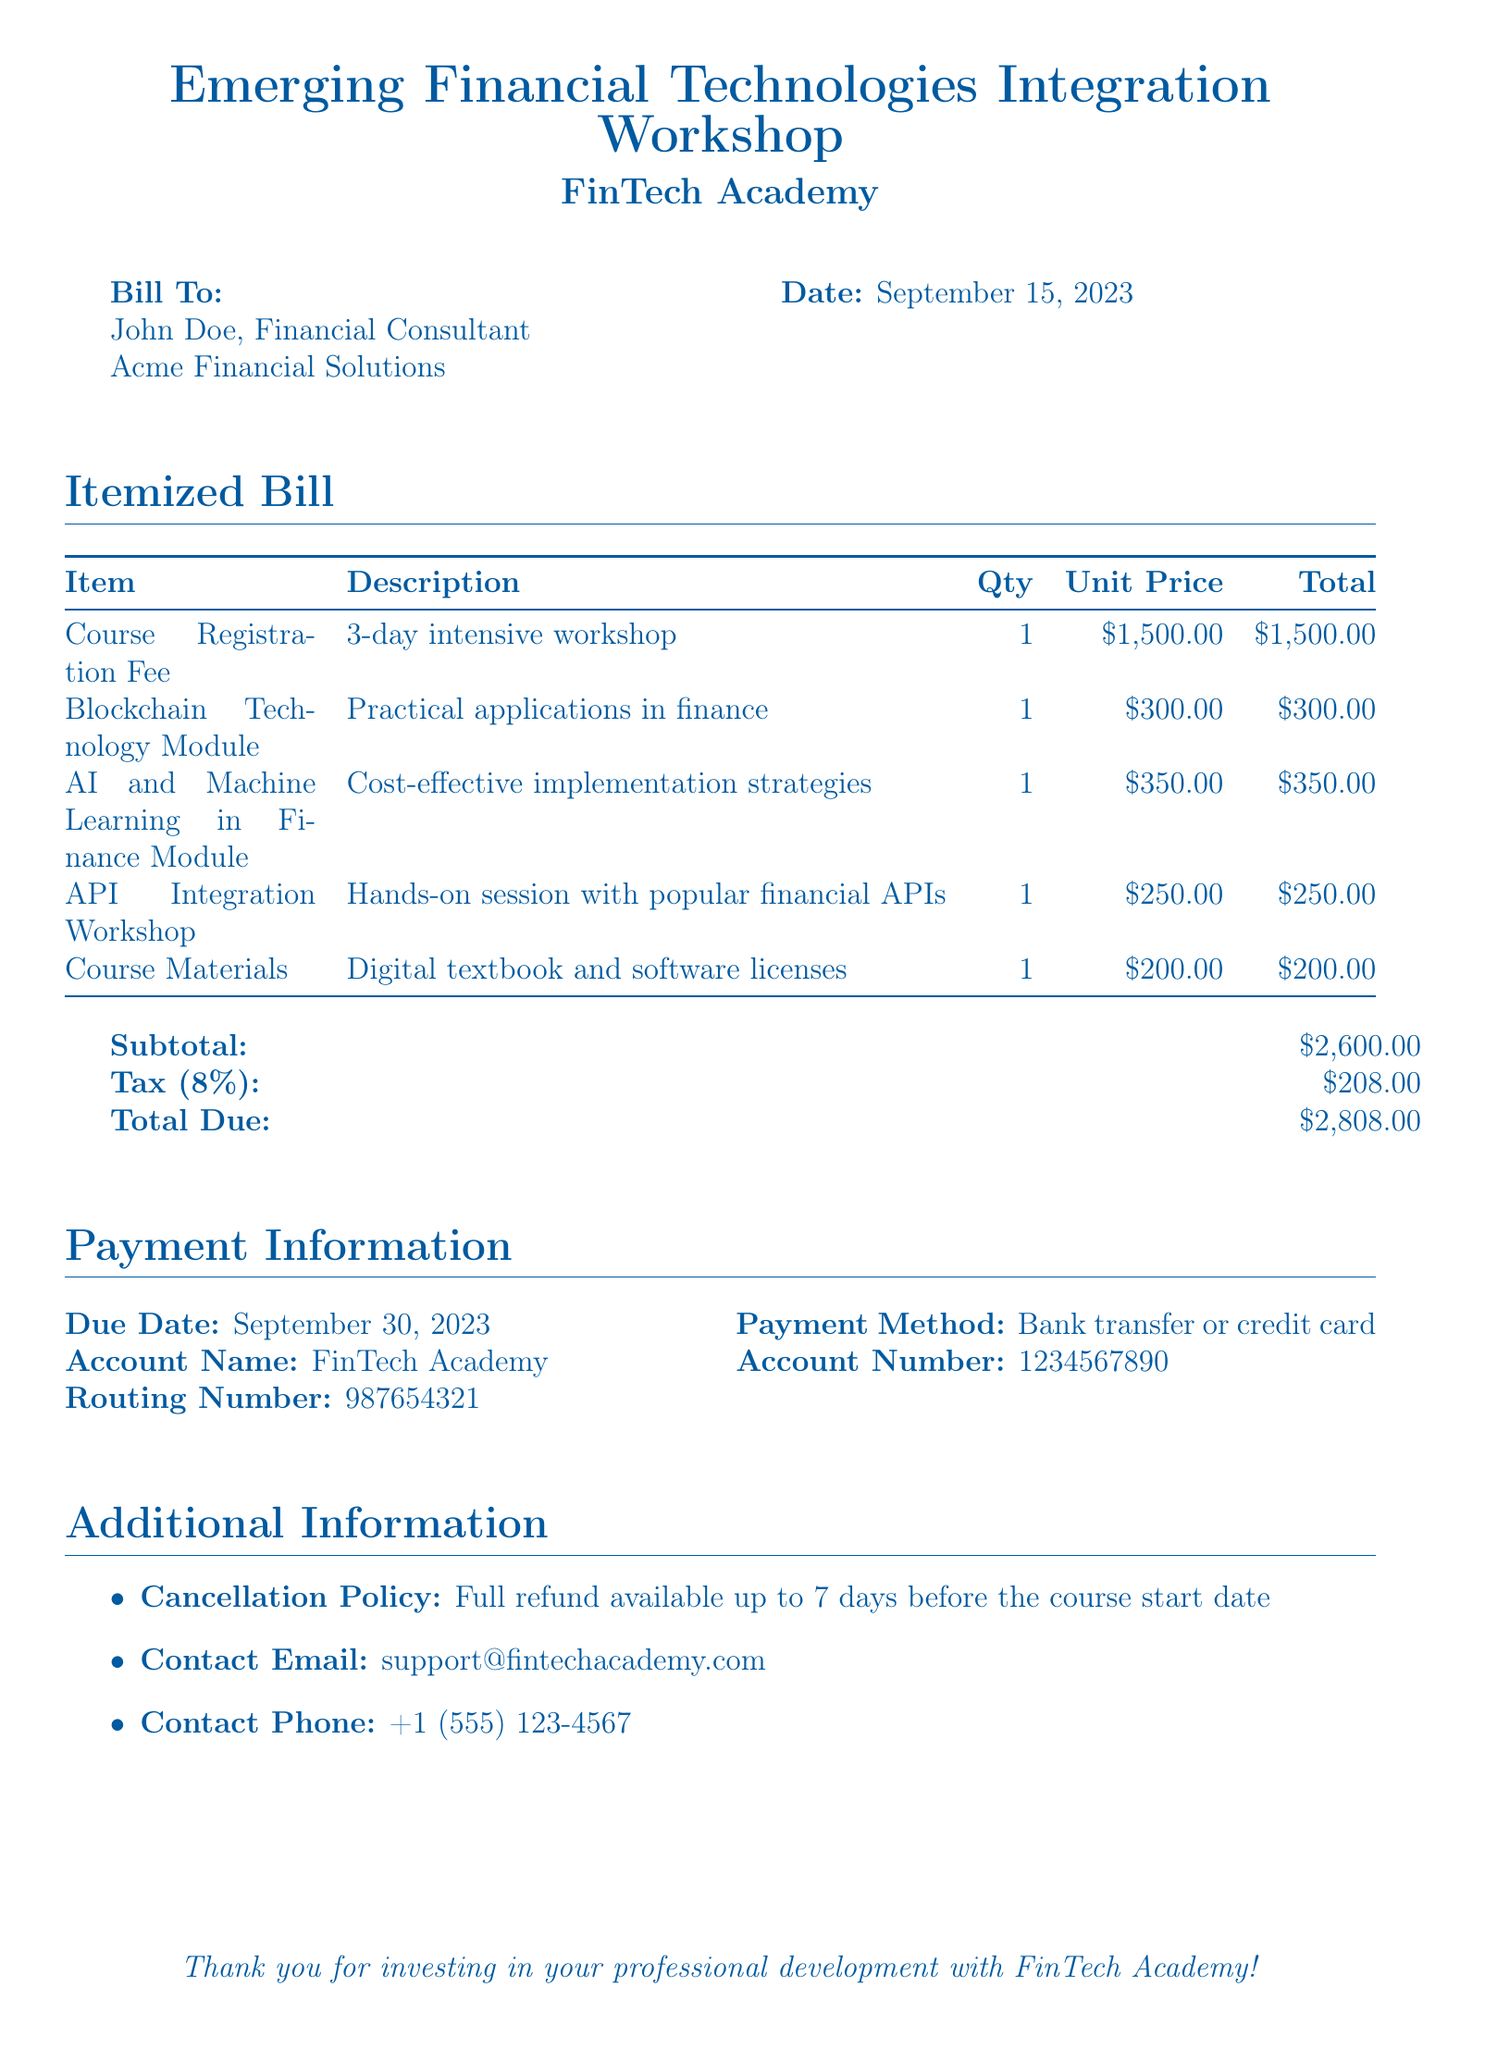What is the total due amount? The total due amount is listed at the bottom of the bill, calculated from the subtotal and tax.
Answer: $2,808.00 What is the course registration fee? The course registration fee is specified as the first item in the bill's itemized list.
Answer: $1,500.00 Who is the bill addressed to? The document specifies the recipient of the bill at the top under "Bill To:".
Answer: John Doe, Financial Consultant What is the due date for payment? The due date for payment is mentioned in the payment information section of the document.
Answer: September 30, 2023 How much is the tax amount? The tax amount is calculated and displayed in the summary of the total due section.
Answer: $208.00 What is the contact email for support? The contact email is provided in the additional information section for any inquiries related to the course.
Answer: support@fintechacademy.com How many modules are included in the course? The itemized list includes individual modules along with the course registration fee.
Answer: 3 What is the cancellation policy? The cancellation policy is stated in the additional information part of the document.
Answer: Full refund available up to 7 days before the course start date What payment methods are accepted? The payment methods are noted in the payment information section under "Payment Method:".
Answer: Bank transfer or credit card 